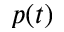Convert formula to latex. <formula><loc_0><loc_0><loc_500><loc_500>p ( t )</formula> 